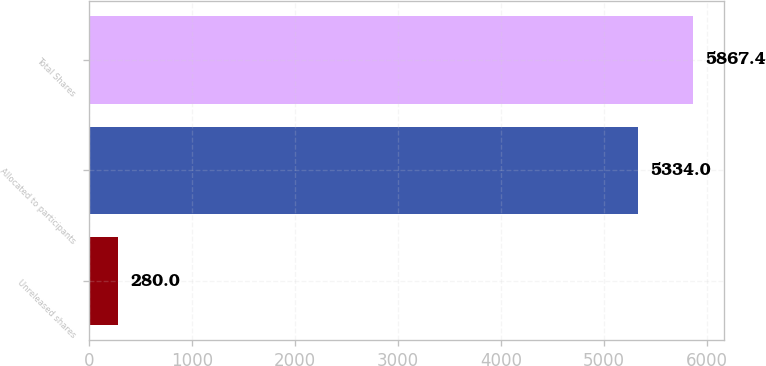Convert chart. <chart><loc_0><loc_0><loc_500><loc_500><bar_chart><fcel>Unreleased shares<fcel>Allocated to participants<fcel>Total Shares<nl><fcel>280<fcel>5334<fcel>5867.4<nl></chart> 